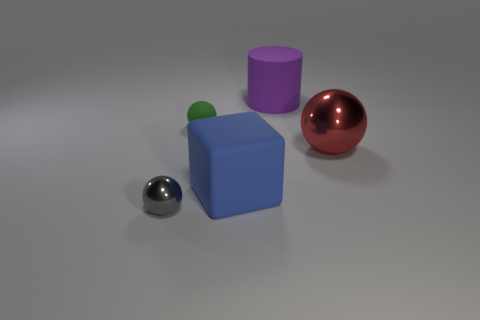Subtract all red spheres. How many spheres are left? 2 Subtract all green matte balls. How many balls are left? 2 Subtract all cubes. How many objects are left? 4 Subtract all blue blocks. How many gray balls are left? 1 Add 1 large red spheres. How many objects exist? 6 Subtract 0 brown spheres. How many objects are left? 5 Subtract 1 spheres. How many spheres are left? 2 Subtract all brown blocks. Subtract all yellow cylinders. How many blocks are left? 1 Subtract all cyan matte objects. Subtract all small green rubber spheres. How many objects are left? 4 Add 4 big purple rubber cylinders. How many big purple rubber cylinders are left? 5 